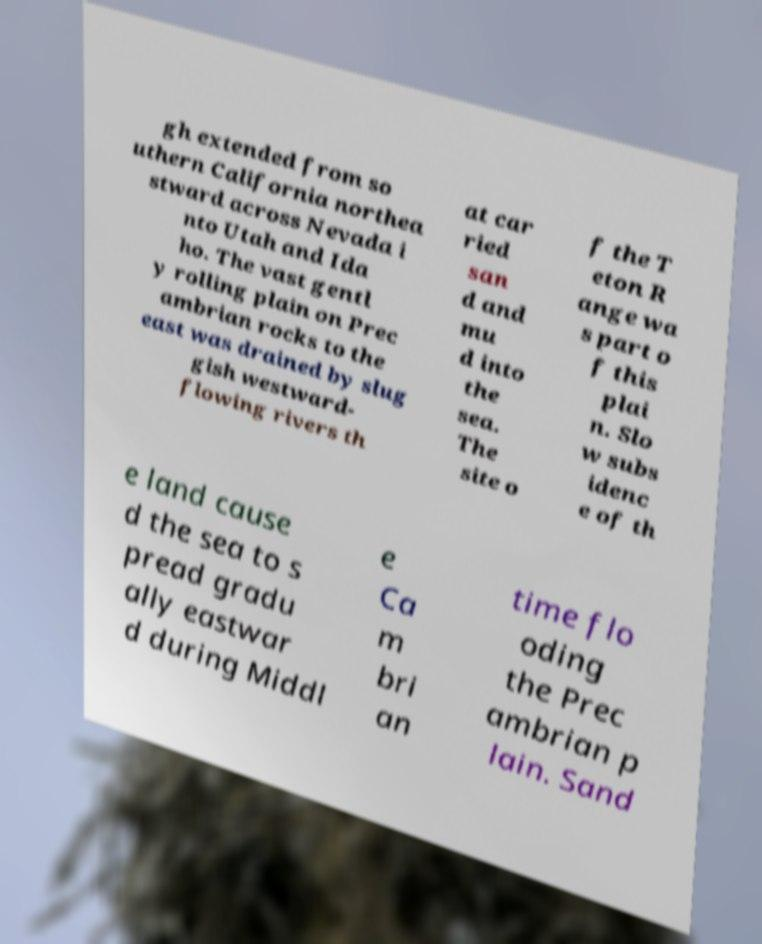What messages or text are displayed in this image? I need them in a readable, typed format. gh extended from so uthern California northea stward across Nevada i nto Utah and Ida ho. The vast gentl y rolling plain on Prec ambrian rocks to the east was drained by slug gish westward- flowing rivers th at car ried san d and mu d into the sea. The site o f the T eton R ange wa s part o f this plai n. Slo w subs idenc e of th e land cause d the sea to s pread gradu ally eastwar d during Middl e Ca m bri an time flo oding the Prec ambrian p lain. Sand 